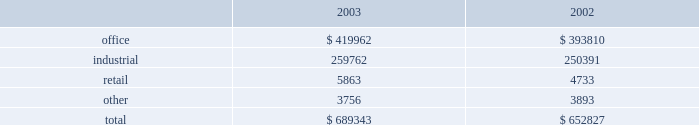Gain on land sales are derived from sales of undeveloped land owned by us .
We pursue opportunities to dispose of land in markets with a high concentration of undeveloped land and in those markets where the land no longer meets our strategic development plans .
The increase was partially attributable to a land sale to a current corporate tenant for potential future expansion .
We recorded $ 424000 and $ 560000 of impairment charges associated with contracts to sell land parcels for the years ended december 31 , 2004 and 2003 , respectively .
As of december 31 , 2004 , only one parcel on which we recorded impairment charges is still owned by us .
We anticipate selling this parcel in the first quarter of 2005 .
Discontinued operations we have classified operations of 86 buildings as discontinued operations as of december 31 , 2004 .
These 86 buildings consist of 69 industrial , 12 office and five retail properties .
As a result , we classified net income from operations , net of minority interest , of $ 1.6 million , $ 6.3 million and $ 10.7 million as net income from discontinued operations for the years ended december 31 , 2004 , 2003 and 2002 , respectively .
In addition , 41 of the properties classified in discontinued operations were sold during 2004 , 42 properties were sold during 2003 , two properties were sold during 2002 and one operating property is classified as held-for-sale at december 31 , 2004 .
The gains on disposal of these properties , net of impairment adjustment and minority interest , of $ 23.9 million and $ 11.8 million for the years ended december 31 , 2004 and 2003 , respectively , are also reported in discontinued operations .
For the year ended december 31 , 2002 , a $ 4.5 million loss on disposal of properties , net of impairment adjustments and minority interest , is reported in discontinued operations due to impairment charges of $ 7.7 million recorded on three properties in 2002 that were later sold in 2003 and 2004 .
Comparison of year ended december 31 , 2003 to year ended december 31 , 2002 rental income from continuing operations rental income from continuing operations increased from $ 652.8 million in 2002 to $ 689.3 million in 2003 .
The table reconciles rental income by reportable segment to our total reported rental income from continuing operations for the years ended december 31 , 2003 and 2002 ( in thousands ) : .
Although our three reportable segments comprising rental operations ( office , industrial and retail ) are all within the real estate industry , they are not necessarily affected by the same economic and industry conditions .
For example , our retail segment experienced high occupancies and strong overall performance during 2003 , while our office and industrial segments reflected the weaker economic environment for those property types .
The primary causes of the increase in rental income from continuing operations , with specific references to a particular segment when applicable , are summarized below : 25cf during 2003 , in-service occupancy improved from 87.1% ( 87.1 % ) at the end of 2002 to 89.3% ( 89.3 % ) at the end of 2003 .
The second half of 2003 was highlighted by a significant increase in the industrial portfolio occupancy of 2.1% ( 2.1 % ) along with a slight increase in office portfolio occupancy of 0.9% ( 0.9 % ) .
25cf lease termination fees totaled $ 27.4 million in 2002 compared to $ 16.2 million in 2003 .
Most of this decrease was attributable to the office segment , which recognized $ 21.1 million of termination fees in 2002 as compared to $ 11.8 million in 2003 .
Lease termination fees relate to specific tenants that pay a fee to terminate their lease obligations before the end of the contractual lease term .
The high volume of termination fees in 2002 was reflective of the contraction of the business of large office users during that year and their desire to downsize their use of office space .
The decrease in termination fees for 2003 was indicative of an improving economy and a more stable financial position of our tenants .
25cf during the year ended 2003 , we acquired $ 232 million of properties totaling 2.1 million square feet .
The acquisitions were primarily class a office buildings in existing markets with overall occupancy near 90% ( 90 % ) .
Revenues associated with these acquisitions totaled $ 11.9 million in 2003 .
In addition , revenues from 2002 acquisitions totaled $ 15.8 million in 2003 compared to $ 4.8 million in 2002 .
This significant increase is primarily due to a large office acquisition that closed at the end of december 2002 .
25cf developments placed in-service in 2003 provided revenues of $ 6.6 million , while revenues associated with developments placed in-service in 2002 totaled $ 13.7 million in 2003 compared to $ 4.7 million in 25cf proceeds from dispositions of held for rental properties totaled $ 126.1 million in 2003 , compared to $ 40.9 million in 2002 .
These properties generated revenue of $ 12.5 million in 2003 versus $ 19.6 million in 2002 .
Equity in earnings of unconsolidated companies equity in earnings represents our ownership share of net income from investments in unconsolidated companies .
These joint ventures generally own and operate rental properties and hold land for development .
These earnings decreased from $ 27.2 million in 2002 to $ 23.7 million in 2003 .
This decrease is a result of the following significant activity: .
What is the percent change in rental income from continuing operations from 2002 to 2003? 
Computations: (((689343 - 652827) / 652827) * 100)
Answer: 5.59352. Gain on land sales are derived from sales of undeveloped land owned by us .
We pursue opportunities to dispose of land in markets with a high concentration of undeveloped land and in those markets where the land no longer meets our strategic development plans .
The increase was partially attributable to a land sale to a current corporate tenant for potential future expansion .
We recorded $ 424000 and $ 560000 of impairment charges associated with contracts to sell land parcels for the years ended december 31 , 2004 and 2003 , respectively .
As of december 31 , 2004 , only one parcel on which we recorded impairment charges is still owned by us .
We anticipate selling this parcel in the first quarter of 2005 .
Discontinued operations we have classified operations of 86 buildings as discontinued operations as of december 31 , 2004 .
These 86 buildings consist of 69 industrial , 12 office and five retail properties .
As a result , we classified net income from operations , net of minority interest , of $ 1.6 million , $ 6.3 million and $ 10.7 million as net income from discontinued operations for the years ended december 31 , 2004 , 2003 and 2002 , respectively .
In addition , 41 of the properties classified in discontinued operations were sold during 2004 , 42 properties were sold during 2003 , two properties were sold during 2002 and one operating property is classified as held-for-sale at december 31 , 2004 .
The gains on disposal of these properties , net of impairment adjustment and minority interest , of $ 23.9 million and $ 11.8 million for the years ended december 31 , 2004 and 2003 , respectively , are also reported in discontinued operations .
For the year ended december 31 , 2002 , a $ 4.5 million loss on disposal of properties , net of impairment adjustments and minority interest , is reported in discontinued operations due to impairment charges of $ 7.7 million recorded on three properties in 2002 that were later sold in 2003 and 2004 .
Comparison of year ended december 31 , 2003 to year ended december 31 , 2002 rental income from continuing operations rental income from continuing operations increased from $ 652.8 million in 2002 to $ 689.3 million in 2003 .
The table reconciles rental income by reportable segment to our total reported rental income from continuing operations for the years ended december 31 , 2003 and 2002 ( in thousands ) : .
Although our three reportable segments comprising rental operations ( office , industrial and retail ) are all within the real estate industry , they are not necessarily affected by the same economic and industry conditions .
For example , our retail segment experienced high occupancies and strong overall performance during 2003 , while our office and industrial segments reflected the weaker economic environment for those property types .
The primary causes of the increase in rental income from continuing operations , with specific references to a particular segment when applicable , are summarized below : 25cf during 2003 , in-service occupancy improved from 87.1% ( 87.1 % ) at the end of 2002 to 89.3% ( 89.3 % ) at the end of 2003 .
The second half of 2003 was highlighted by a significant increase in the industrial portfolio occupancy of 2.1% ( 2.1 % ) along with a slight increase in office portfolio occupancy of 0.9% ( 0.9 % ) .
25cf lease termination fees totaled $ 27.4 million in 2002 compared to $ 16.2 million in 2003 .
Most of this decrease was attributable to the office segment , which recognized $ 21.1 million of termination fees in 2002 as compared to $ 11.8 million in 2003 .
Lease termination fees relate to specific tenants that pay a fee to terminate their lease obligations before the end of the contractual lease term .
The high volume of termination fees in 2002 was reflective of the contraction of the business of large office users during that year and their desire to downsize their use of office space .
The decrease in termination fees for 2003 was indicative of an improving economy and a more stable financial position of our tenants .
25cf during the year ended 2003 , we acquired $ 232 million of properties totaling 2.1 million square feet .
The acquisitions were primarily class a office buildings in existing markets with overall occupancy near 90% ( 90 % ) .
Revenues associated with these acquisitions totaled $ 11.9 million in 2003 .
In addition , revenues from 2002 acquisitions totaled $ 15.8 million in 2003 compared to $ 4.8 million in 2002 .
This significant increase is primarily due to a large office acquisition that closed at the end of december 2002 .
25cf developments placed in-service in 2003 provided revenues of $ 6.6 million , while revenues associated with developments placed in-service in 2002 totaled $ 13.7 million in 2003 compared to $ 4.7 million in 25cf proceeds from dispositions of held for rental properties totaled $ 126.1 million in 2003 , compared to $ 40.9 million in 2002 .
These properties generated revenue of $ 12.5 million in 2003 versus $ 19.6 million in 2002 .
Equity in earnings of unconsolidated companies equity in earnings represents our ownership share of net income from investments in unconsolidated companies .
These joint ventures generally own and operate rental properties and hold land for development .
These earnings decreased from $ 27.2 million in 2002 to $ 23.7 million in 2003 .
This decrease is a result of the following significant activity: .
Inn 2003 what was the percent of the total rental income by reportable segment that was sourced from retail? 
Computations: (5863 / 689343)
Answer: 0.00851. Gain on land sales are derived from sales of undeveloped land owned by us .
We pursue opportunities to dispose of land in markets with a high concentration of undeveloped land and in those markets where the land no longer meets our strategic development plans .
The increase was partially attributable to a land sale to a current corporate tenant for potential future expansion .
We recorded $ 424000 and $ 560000 of impairment charges associated with contracts to sell land parcels for the years ended december 31 , 2004 and 2003 , respectively .
As of december 31 , 2004 , only one parcel on which we recorded impairment charges is still owned by us .
We anticipate selling this parcel in the first quarter of 2005 .
Discontinued operations we have classified operations of 86 buildings as discontinued operations as of december 31 , 2004 .
These 86 buildings consist of 69 industrial , 12 office and five retail properties .
As a result , we classified net income from operations , net of minority interest , of $ 1.6 million , $ 6.3 million and $ 10.7 million as net income from discontinued operations for the years ended december 31 , 2004 , 2003 and 2002 , respectively .
In addition , 41 of the properties classified in discontinued operations were sold during 2004 , 42 properties were sold during 2003 , two properties were sold during 2002 and one operating property is classified as held-for-sale at december 31 , 2004 .
The gains on disposal of these properties , net of impairment adjustment and minority interest , of $ 23.9 million and $ 11.8 million for the years ended december 31 , 2004 and 2003 , respectively , are also reported in discontinued operations .
For the year ended december 31 , 2002 , a $ 4.5 million loss on disposal of properties , net of impairment adjustments and minority interest , is reported in discontinued operations due to impairment charges of $ 7.7 million recorded on three properties in 2002 that were later sold in 2003 and 2004 .
Comparison of year ended december 31 , 2003 to year ended december 31 , 2002 rental income from continuing operations rental income from continuing operations increased from $ 652.8 million in 2002 to $ 689.3 million in 2003 .
The table reconciles rental income by reportable segment to our total reported rental income from continuing operations for the years ended december 31 , 2003 and 2002 ( in thousands ) : .
Although our three reportable segments comprising rental operations ( office , industrial and retail ) are all within the real estate industry , they are not necessarily affected by the same economic and industry conditions .
For example , our retail segment experienced high occupancies and strong overall performance during 2003 , while our office and industrial segments reflected the weaker economic environment for those property types .
The primary causes of the increase in rental income from continuing operations , with specific references to a particular segment when applicable , are summarized below : 25cf during 2003 , in-service occupancy improved from 87.1% ( 87.1 % ) at the end of 2002 to 89.3% ( 89.3 % ) at the end of 2003 .
The second half of 2003 was highlighted by a significant increase in the industrial portfolio occupancy of 2.1% ( 2.1 % ) along with a slight increase in office portfolio occupancy of 0.9% ( 0.9 % ) .
25cf lease termination fees totaled $ 27.4 million in 2002 compared to $ 16.2 million in 2003 .
Most of this decrease was attributable to the office segment , which recognized $ 21.1 million of termination fees in 2002 as compared to $ 11.8 million in 2003 .
Lease termination fees relate to specific tenants that pay a fee to terminate their lease obligations before the end of the contractual lease term .
The high volume of termination fees in 2002 was reflective of the contraction of the business of large office users during that year and their desire to downsize their use of office space .
The decrease in termination fees for 2003 was indicative of an improving economy and a more stable financial position of our tenants .
25cf during the year ended 2003 , we acquired $ 232 million of properties totaling 2.1 million square feet .
The acquisitions were primarily class a office buildings in existing markets with overall occupancy near 90% ( 90 % ) .
Revenues associated with these acquisitions totaled $ 11.9 million in 2003 .
In addition , revenues from 2002 acquisitions totaled $ 15.8 million in 2003 compared to $ 4.8 million in 2002 .
This significant increase is primarily due to a large office acquisition that closed at the end of december 2002 .
25cf developments placed in-service in 2003 provided revenues of $ 6.6 million , while revenues associated with developments placed in-service in 2002 totaled $ 13.7 million in 2003 compared to $ 4.7 million in 25cf proceeds from dispositions of held for rental properties totaled $ 126.1 million in 2003 , compared to $ 40.9 million in 2002 .
These properties generated revenue of $ 12.5 million in 2003 versus $ 19.6 million in 2002 .
Equity in earnings of unconsolidated companies equity in earnings represents our ownership share of net income from investments in unconsolidated companies .
These joint ventures generally own and operate rental properties and hold land for development .
These earnings decreased from $ 27.2 million in 2002 to $ 23.7 million in 2003 .
This decrease is a result of the following significant activity: .
What are the lease termination fees as a percentage of rental income from continuing operations in 2003? 
Computations: ((16.2 / 689.3) * 100)
Answer: 2.35021. 